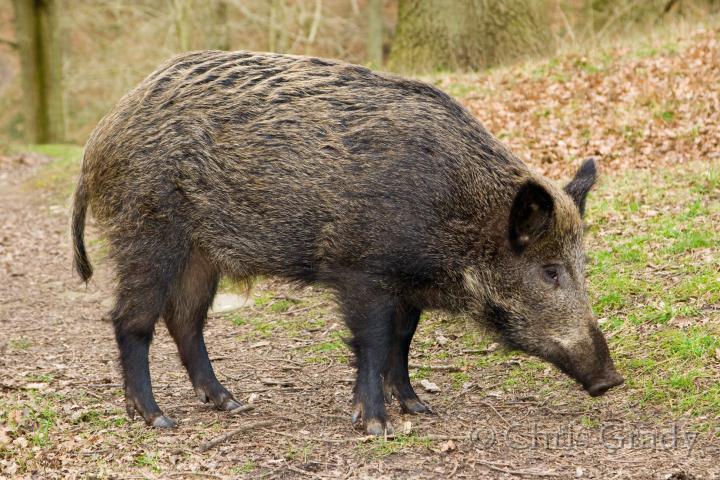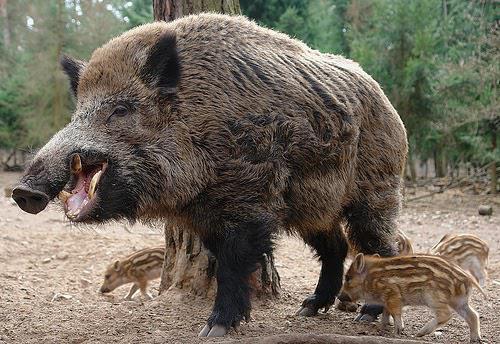The first image is the image on the left, the second image is the image on the right. Assess this claim about the two images: "There are at least two baby boars in one of the images.". Correct or not? Answer yes or no. Yes. 